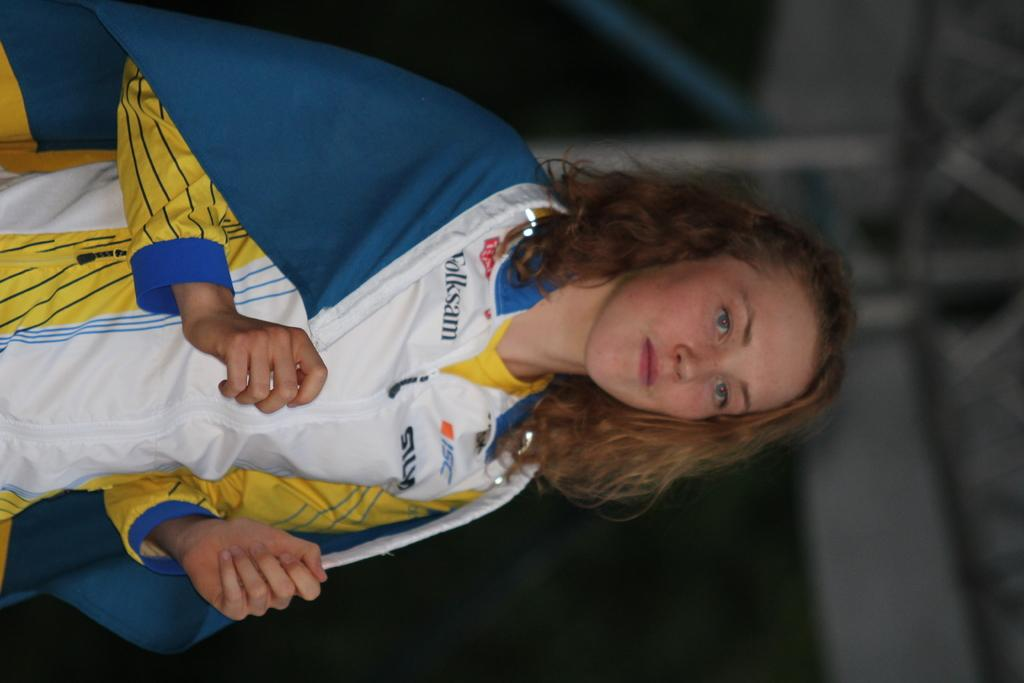<image>
Summarize the visual content of the image. A woman is wearing a short that has ISC in blue on the front. 